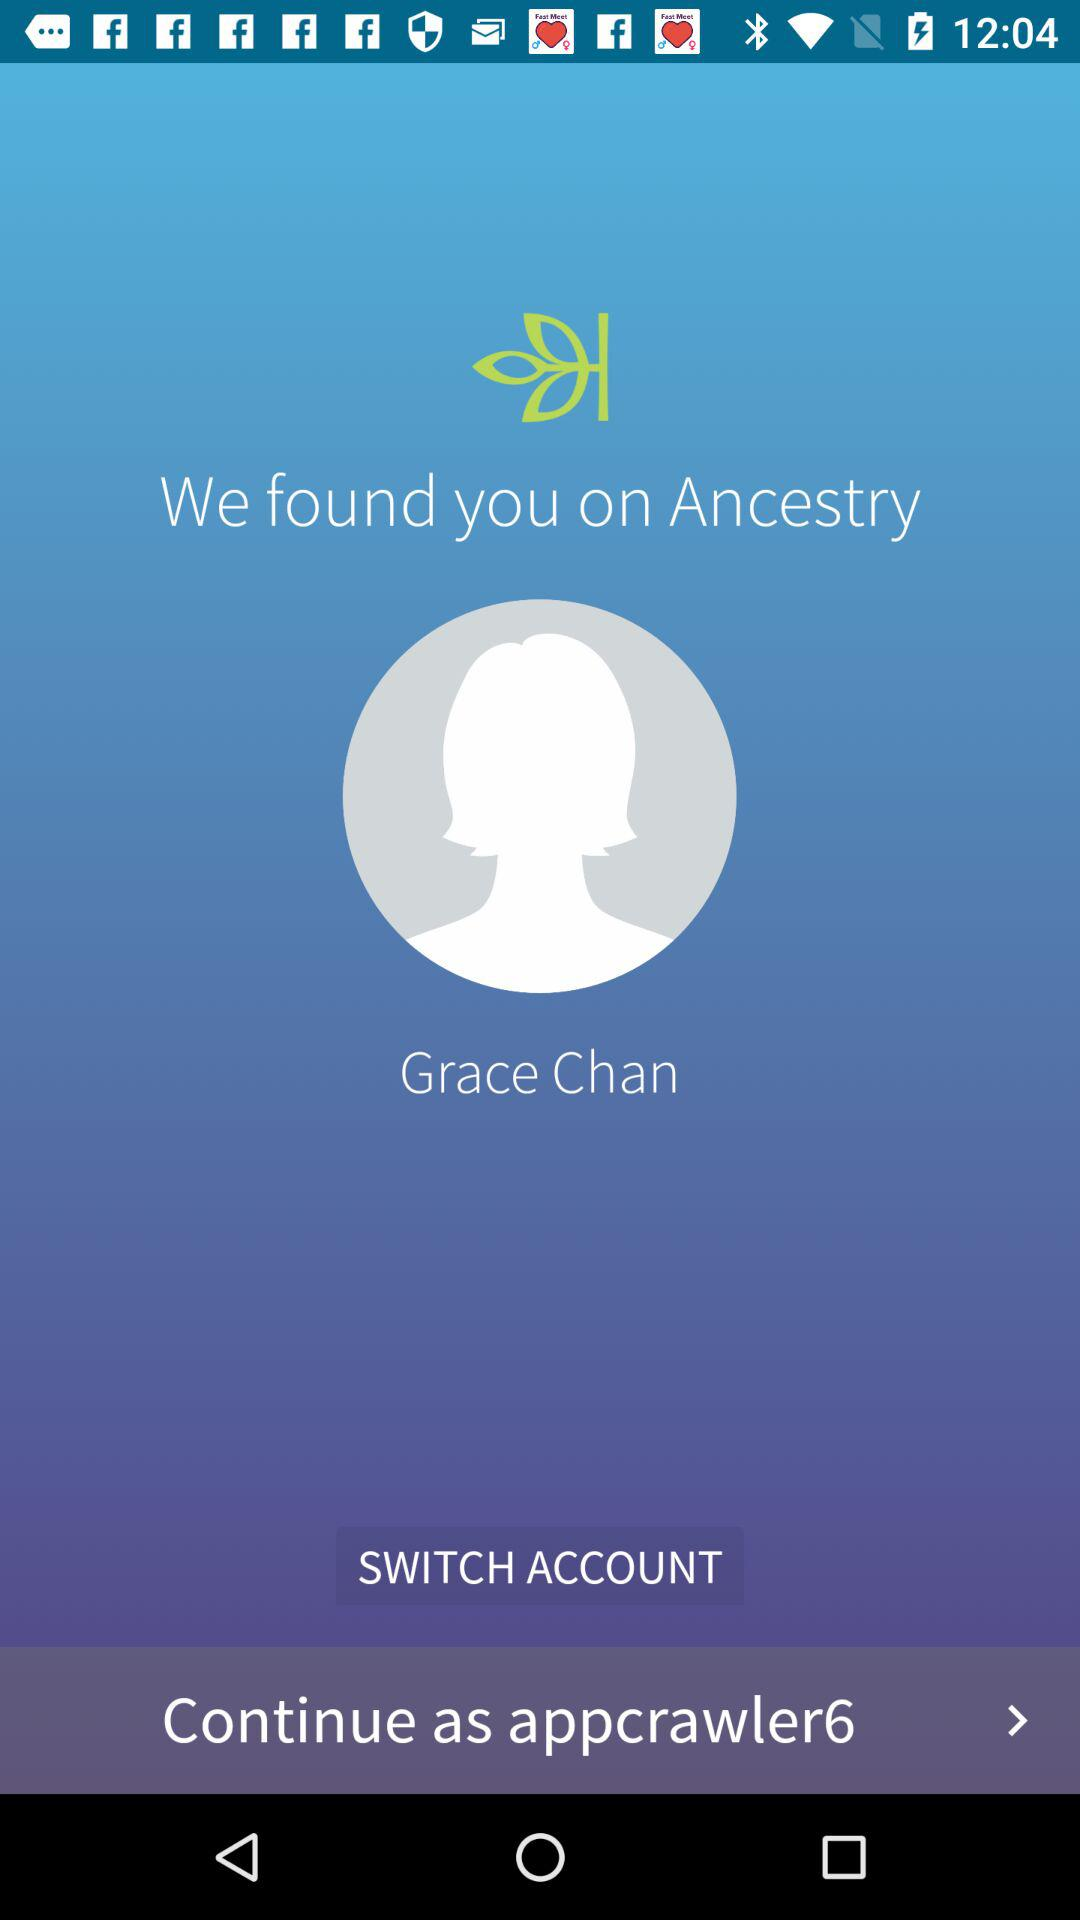What's the user profile name? The user profile name is Grace Chan. 